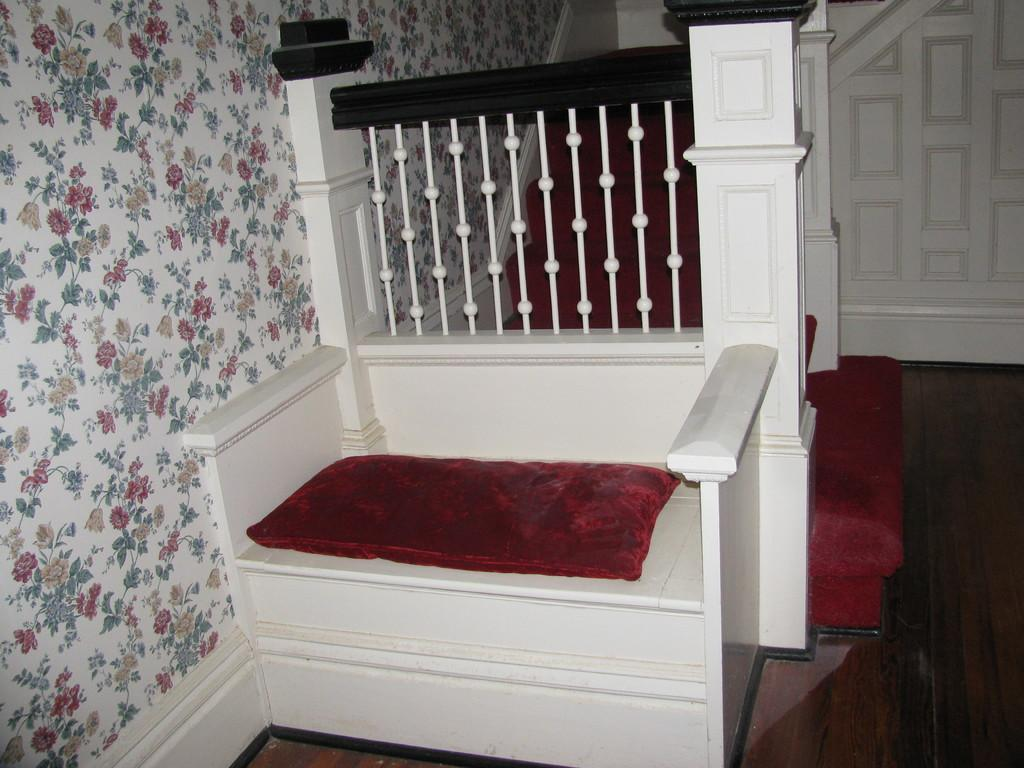What is located in the center of the image? There is a sitting place in the center of the image. What is placed on the sitting place? A cushion is placed on the sitting place. What can be seen on the right side of the image? There is a door on the right side of the image. What architectural features are visible in the background of the image? There are stairs and a wall in the background of the image. How many sheep can be seen attempting to fit into the frame of the image? There are no sheep present in the image, and therefore no such attempt can be observed. 